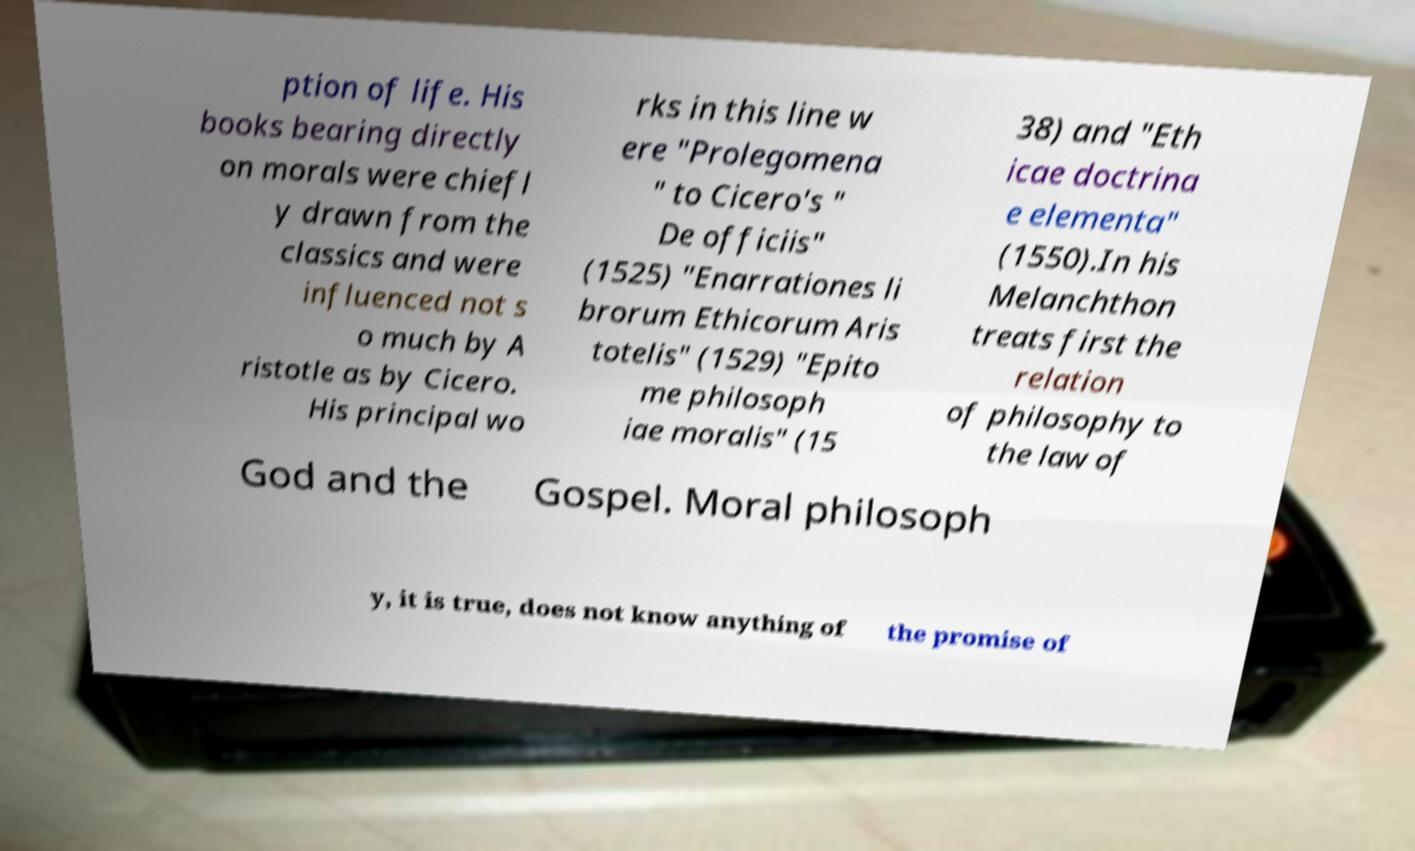There's text embedded in this image that I need extracted. Can you transcribe it verbatim? ption of life. His books bearing directly on morals were chiefl y drawn from the classics and were influenced not s o much by A ristotle as by Cicero. His principal wo rks in this line w ere "Prolegomena " to Cicero's " De officiis" (1525) "Enarrationes li brorum Ethicorum Aris totelis" (1529) "Epito me philosoph iae moralis" (15 38) and "Eth icae doctrina e elementa" (1550).In his Melanchthon treats first the relation of philosophy to the law of God and the Gospel. Moral philosoph y, it is true, does not know anything of the promise of 